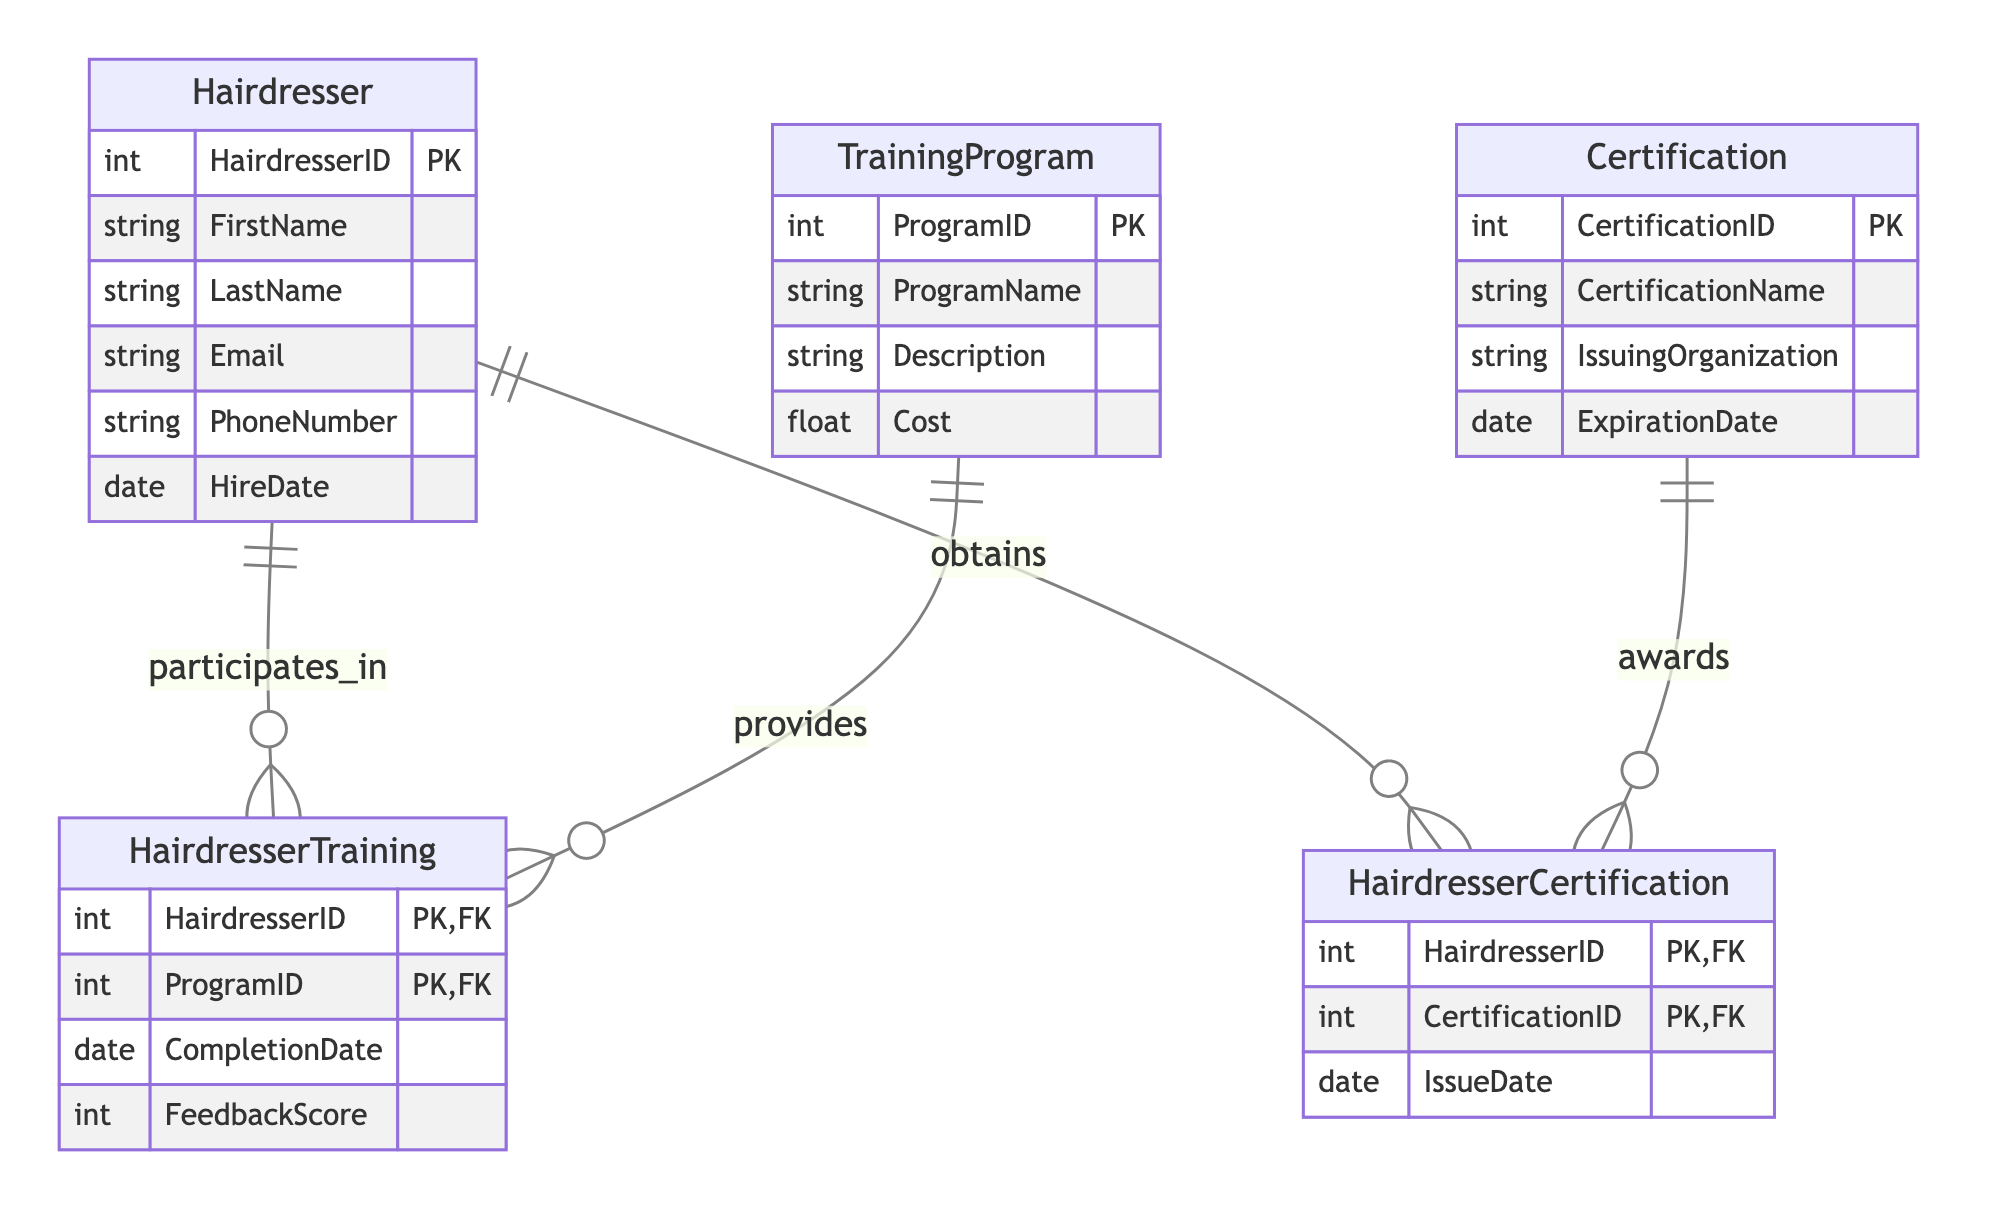What is the primary key of the Hairdresser entity? The primary key for the Hairdresser entity, as defined in the diagram, is the HairdresserID attribute, which uniquely identifies each hairdresser.
Answer: HairdresserID How many entities are present in the diagram? The diagram includes a total of five entities, which are Hairdresser, TrainingProgram, Certification, HairdresserTraining, and HairdresserCertification.
Answer: Five What relationship exists between Hairdresser and HairdresserTraining? The diagram shows that the relationship between Hairdresser and HairdresserTraining is that a hairdresser "participates in" training programs, indicating a many-to-one relationship.
Answer: Participates in What is the attribute represented in the HairdresserTraining for completion? In the HairdresserTraining entity, the attribute representing when a hairdresser completed a training program is the CompletionDate attribute.
Answer: CompletionDate How many foreign keys are in the HairdresserCertification entity? The HairdresserCertification entity has two foreign keys: HairdresserID and CertificationID, which reference the Hairdresser and Certification entities, respectively.
Answer: Two What is the role of the TrainingProgram entity in the diagram? The role of the TrainingProgram entity is to provide various training programs that hairdressers can participate in, linking it to the HairdresserTraining entity.
Answer: Provides Which entity corresponds to certifications obtained by hairdressers? The entity that corresponds to the certifications obtained by hairdressers is the HairdresserCertification entity, which records the details of each certification.
Answer: HairdresserCertification What is the primary key of the HairdresserTraining entity? The primary key of the HairdresserTraining entity is a composite key consisting of HairdresserID and ProgramID, which together uniquely identify each training record.
Answer: HairdresserID, ProgramID What does the Certification entity represent in the context of the diagram? The Certification entity represents the various certifications available to hairdressers, specifying details such as CertificationName, IssuingOrganization, and ExpirationDate.
Answer: Certifications available What is the foreign key that connects HairdresserTraining to TrainingProgram? The foreign key that connects HairdresserTraining to TrainingProgram is ProgramID, which references the ProgramID in the TrainingProgram entity.
Answer: ProgramID 